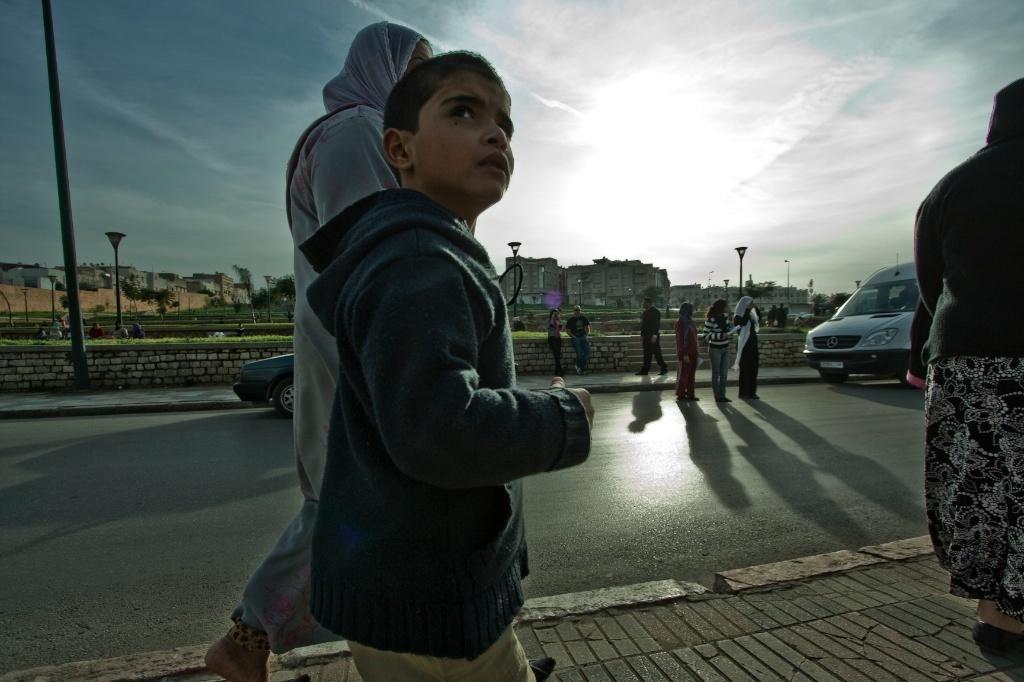How would you summarize this image in a sentence or two? This picture is clicked outside. In the center we can see the group of persons and the group of vehicles seems to be running on the road. In the background we can see the sky, poles, buildings, trees and many other objects. 